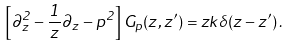<formula> <loc_0><loc_0><loc_500><loc_500>\left [ \partial _ { z } ^ { 2 } - \frac { 1 } { z } \partial _ { z } - p ^ { 2 } \right ] G _ { p } ( z , z ^ { \prime } ) = z k \delta ( z - z ^ { \prime } ) \, .</formula> 